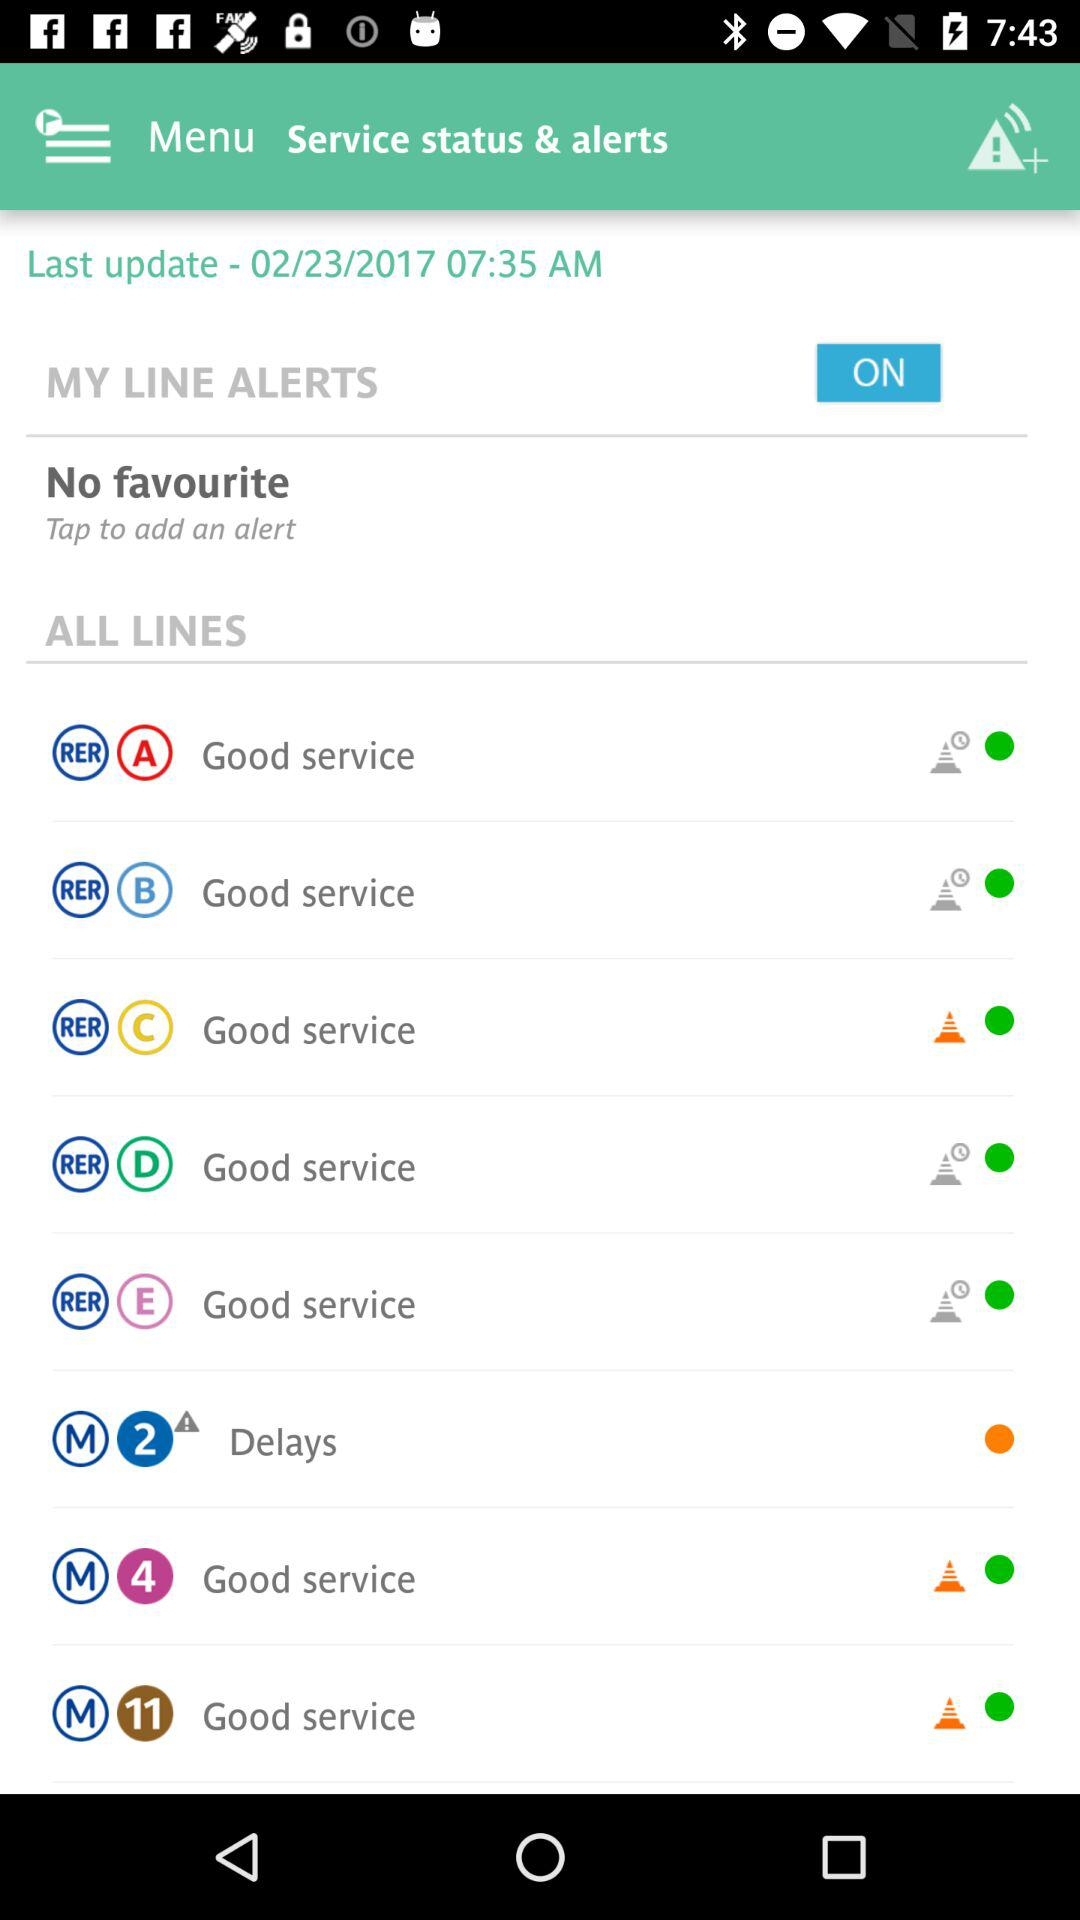What is the time of the last update? The last update was made at 07:35 AM. 